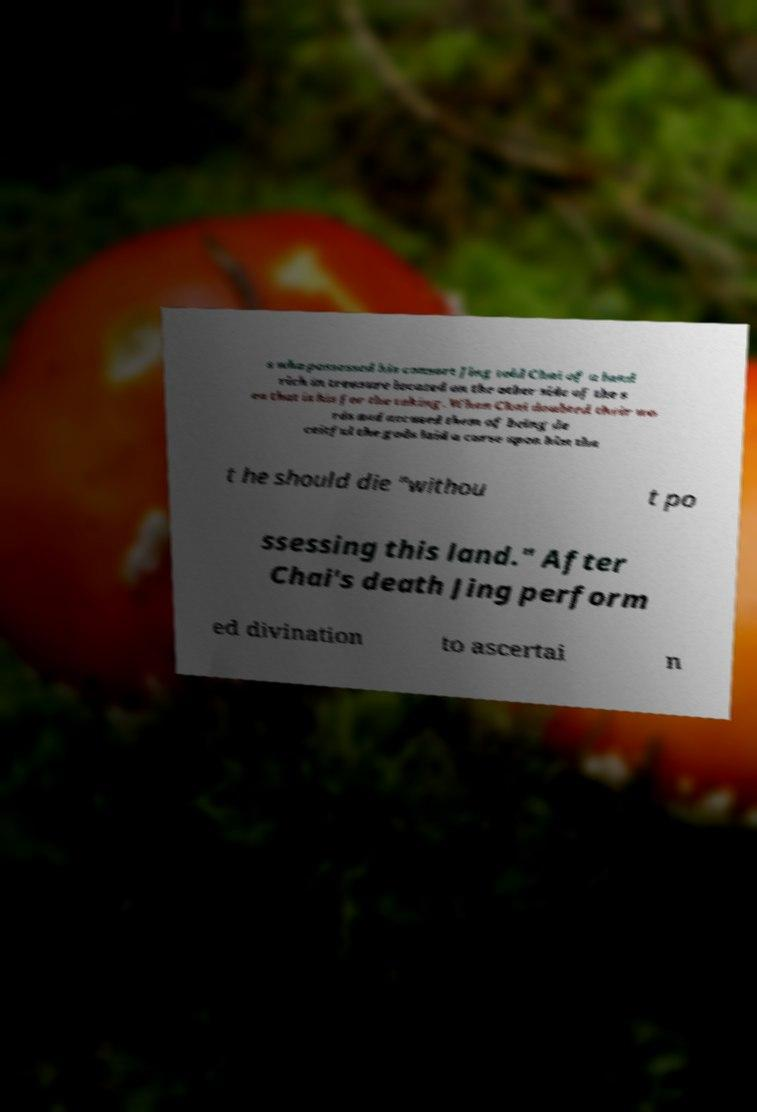There's text embedded in this image that I need extracted. Can you transcribe it verbatim? s who possessed his consort Jing told Chai of a land rich in treasure located on the other side of the s ea that is his for the taking. When Chai doubted their wo rds and accused them of being de ceitful the gods laid a curse upon him tha t he should die "withou t po ssessing this land." After Chai's death Jing perform ed divination to ascertai n 